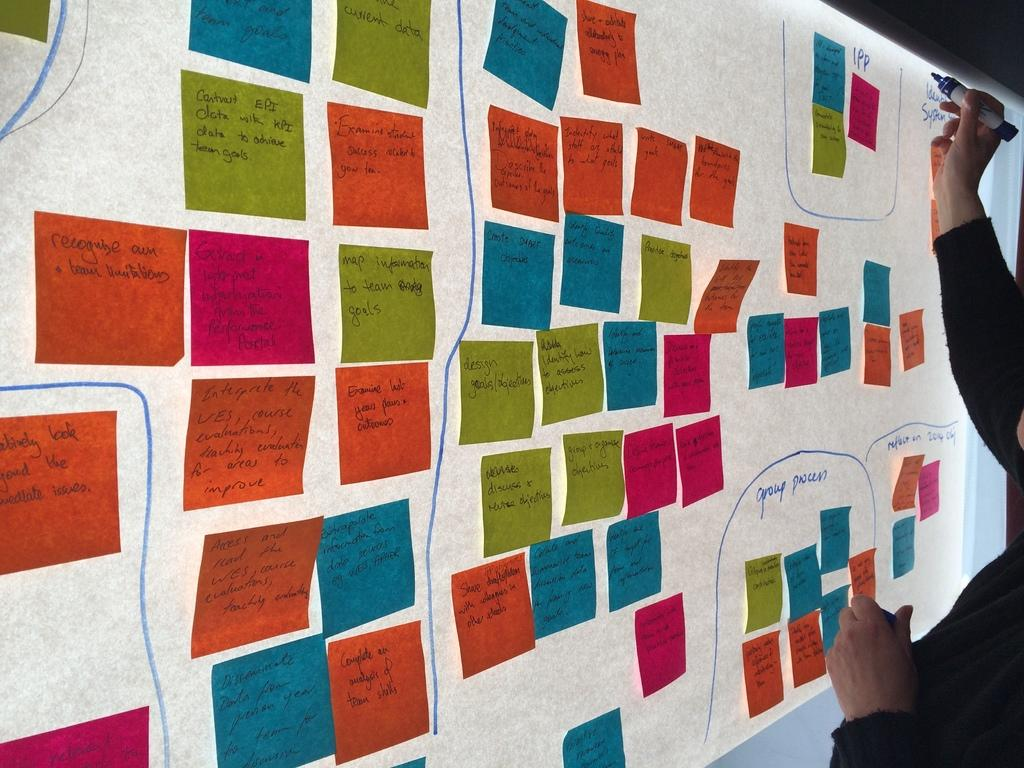What is the main object in the image? There is a screen in the image. What is on the screen? Colored papers are pasted on the screen, and text is written on it. What is the person in the image doing? The person is making something on the screen. What type of vessel is being used by the person in the image? There is no vessel present in the image; the person is working on a screen. What achievement has the person in the image recently accomplished? There is no information about any achievements in the image; it only shows a person working on a screen. 